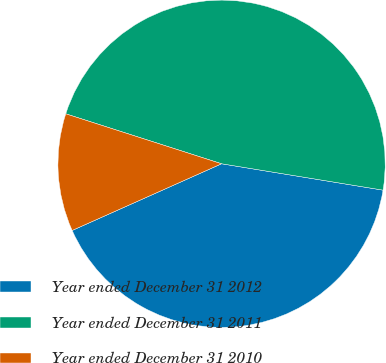<chart> <loc_0><loc_0><loc_500><loc_500><pie_chart><fcel>Year ended December 31 2012<fcel>Year ended December 31 2011<fcel>Year ended December 31 2010<nl><fcel>40.74%<fcel>47.64%<fcel>11.62%<nl></chart> 